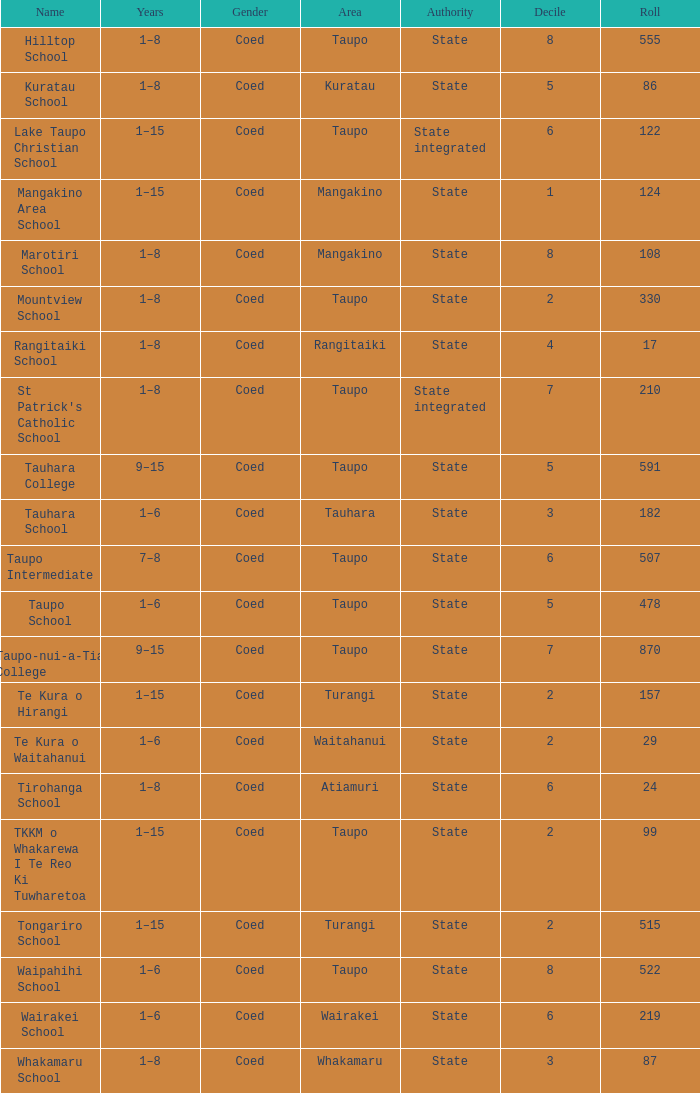Where is the state-authorized school with a roster of more than 157 pupils? Taupo, Taupo, Taupo, Tauhara, Taupo, Taupo, Taupo, Turangi, Taupo, Wairakei. 